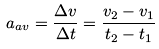<formula> <loc_0><loc_0><loc_500><loc_500>a _ { a v } = { \frac { \Delta v } { \Delta t } } = { \frac { v _ { 2 } - v _ { 1 } } { t _ { 2 } - t _ { 1 } } }</formula> 